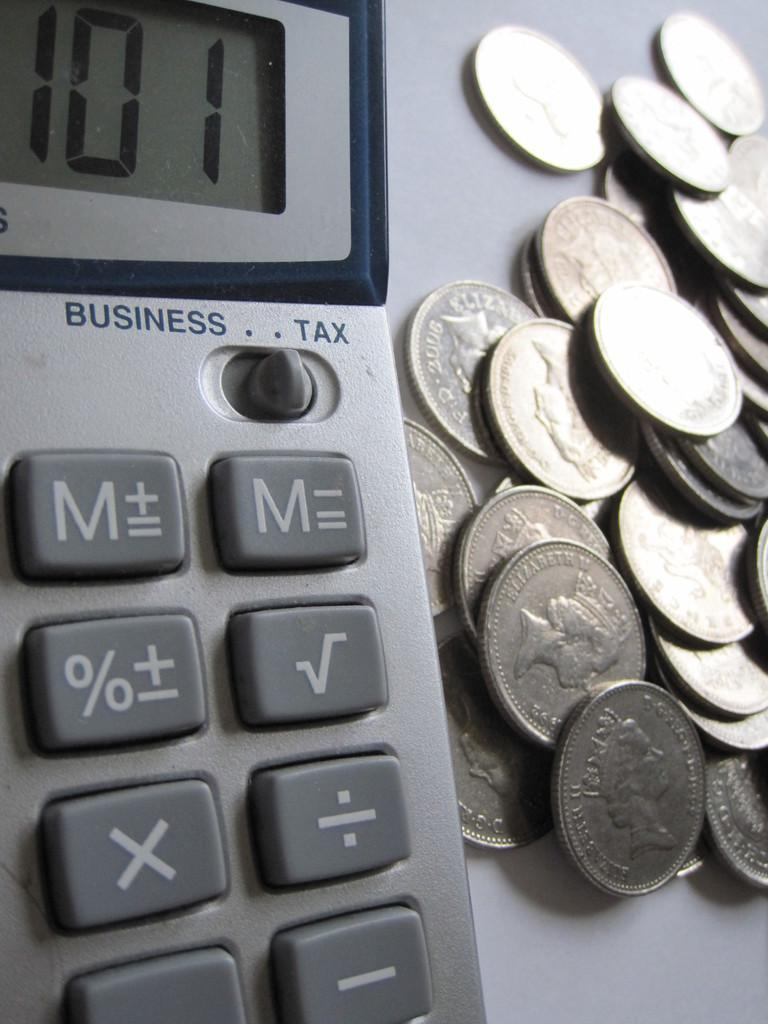<image>
Relay a brief, clear account of the picture shown. A bunch of coins sit next to a calculator, which reads 101 